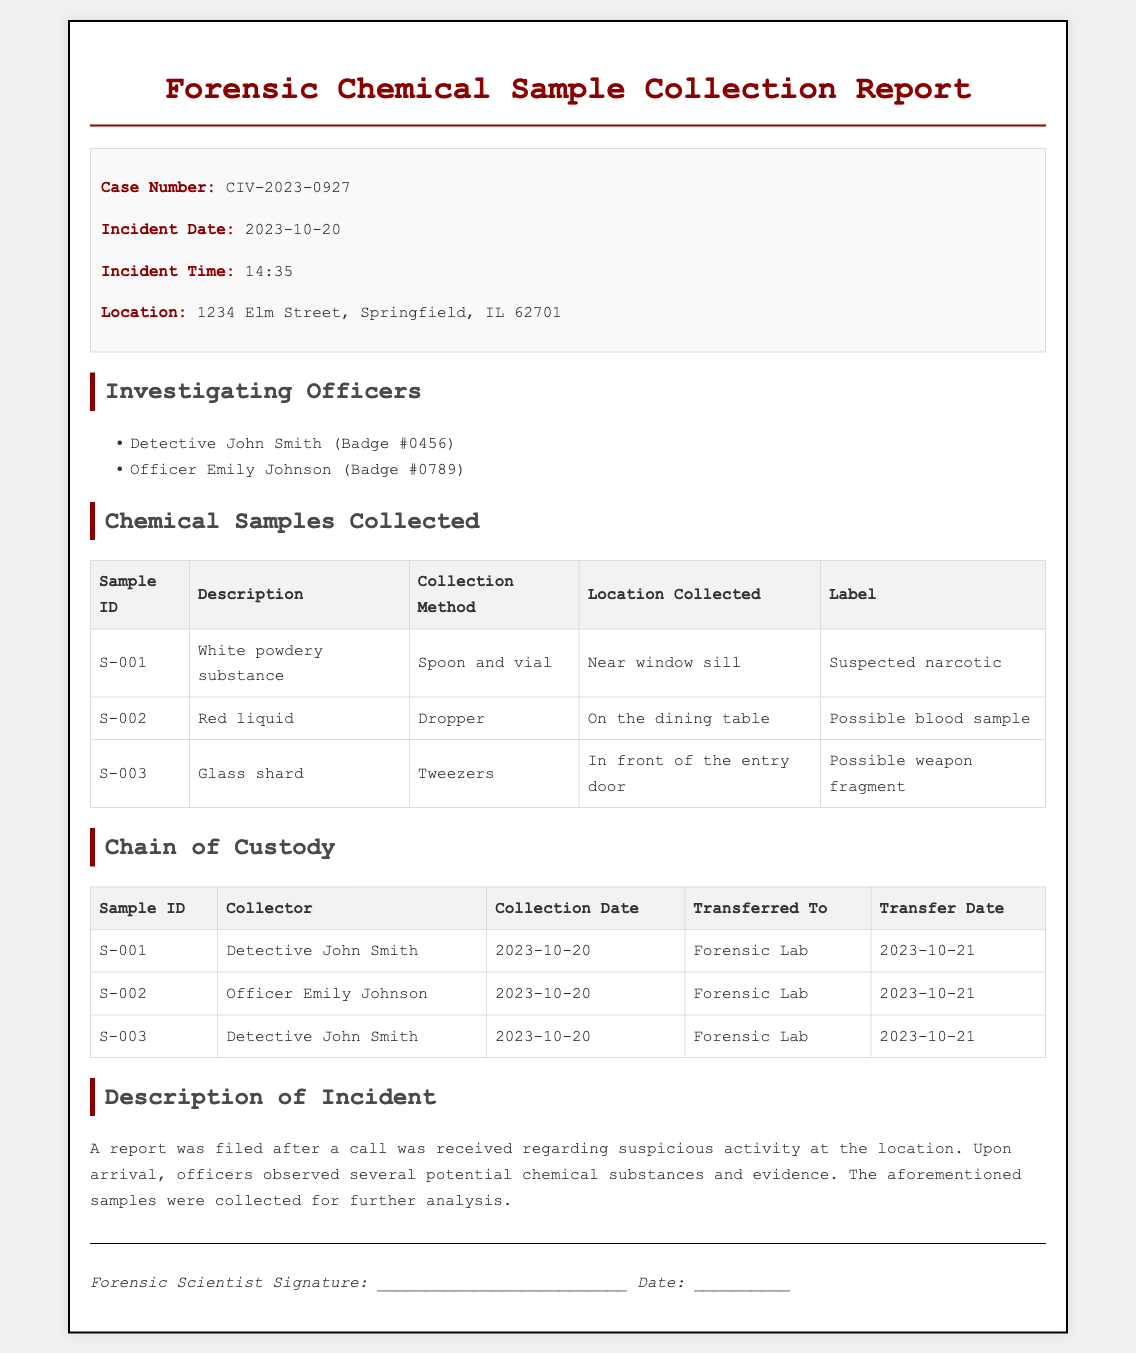What is the case number? The case number is the unique identifier for this incident and is listed in the report.
Answer: CIV-2023-0927 What is the incident date? The incident date indicates when the reported event took place and is provided in the document.
Answer: 2023-10-20 Who collected the white powdery substance? The collector of each sample is listed in the chain of custody section of the document.
Answer: Detective John Smith What is the collection method for the red liquid? The method used to collect each sample is specified in the table of chemical samples collected.
Answer: Dropper How many samples were collected? The total number of chemical samples is indicated by the number of entries in the chemical samples table.
Answer: 3 What was the location of the white powdery substance? The specific location where each sample was collected is described in the chemical samples collected table.
Answer: Near window sill What date were the samples transferred to the Forensic Lab? The transfer date indicates when each sample was moved to the next entity and is found in the chain of custody table.
Answer: 2023-10-21 What is the possible identification of sample S-002? Each sample has a label indicating what it might be, found in the description column of the samples collected table.
Answer: Possible blood sample What type of document is this? The document is a specific type of report related to forensic investigations, as indicated in the title.
Answer: Forensic Chemical Sample Collection Report 